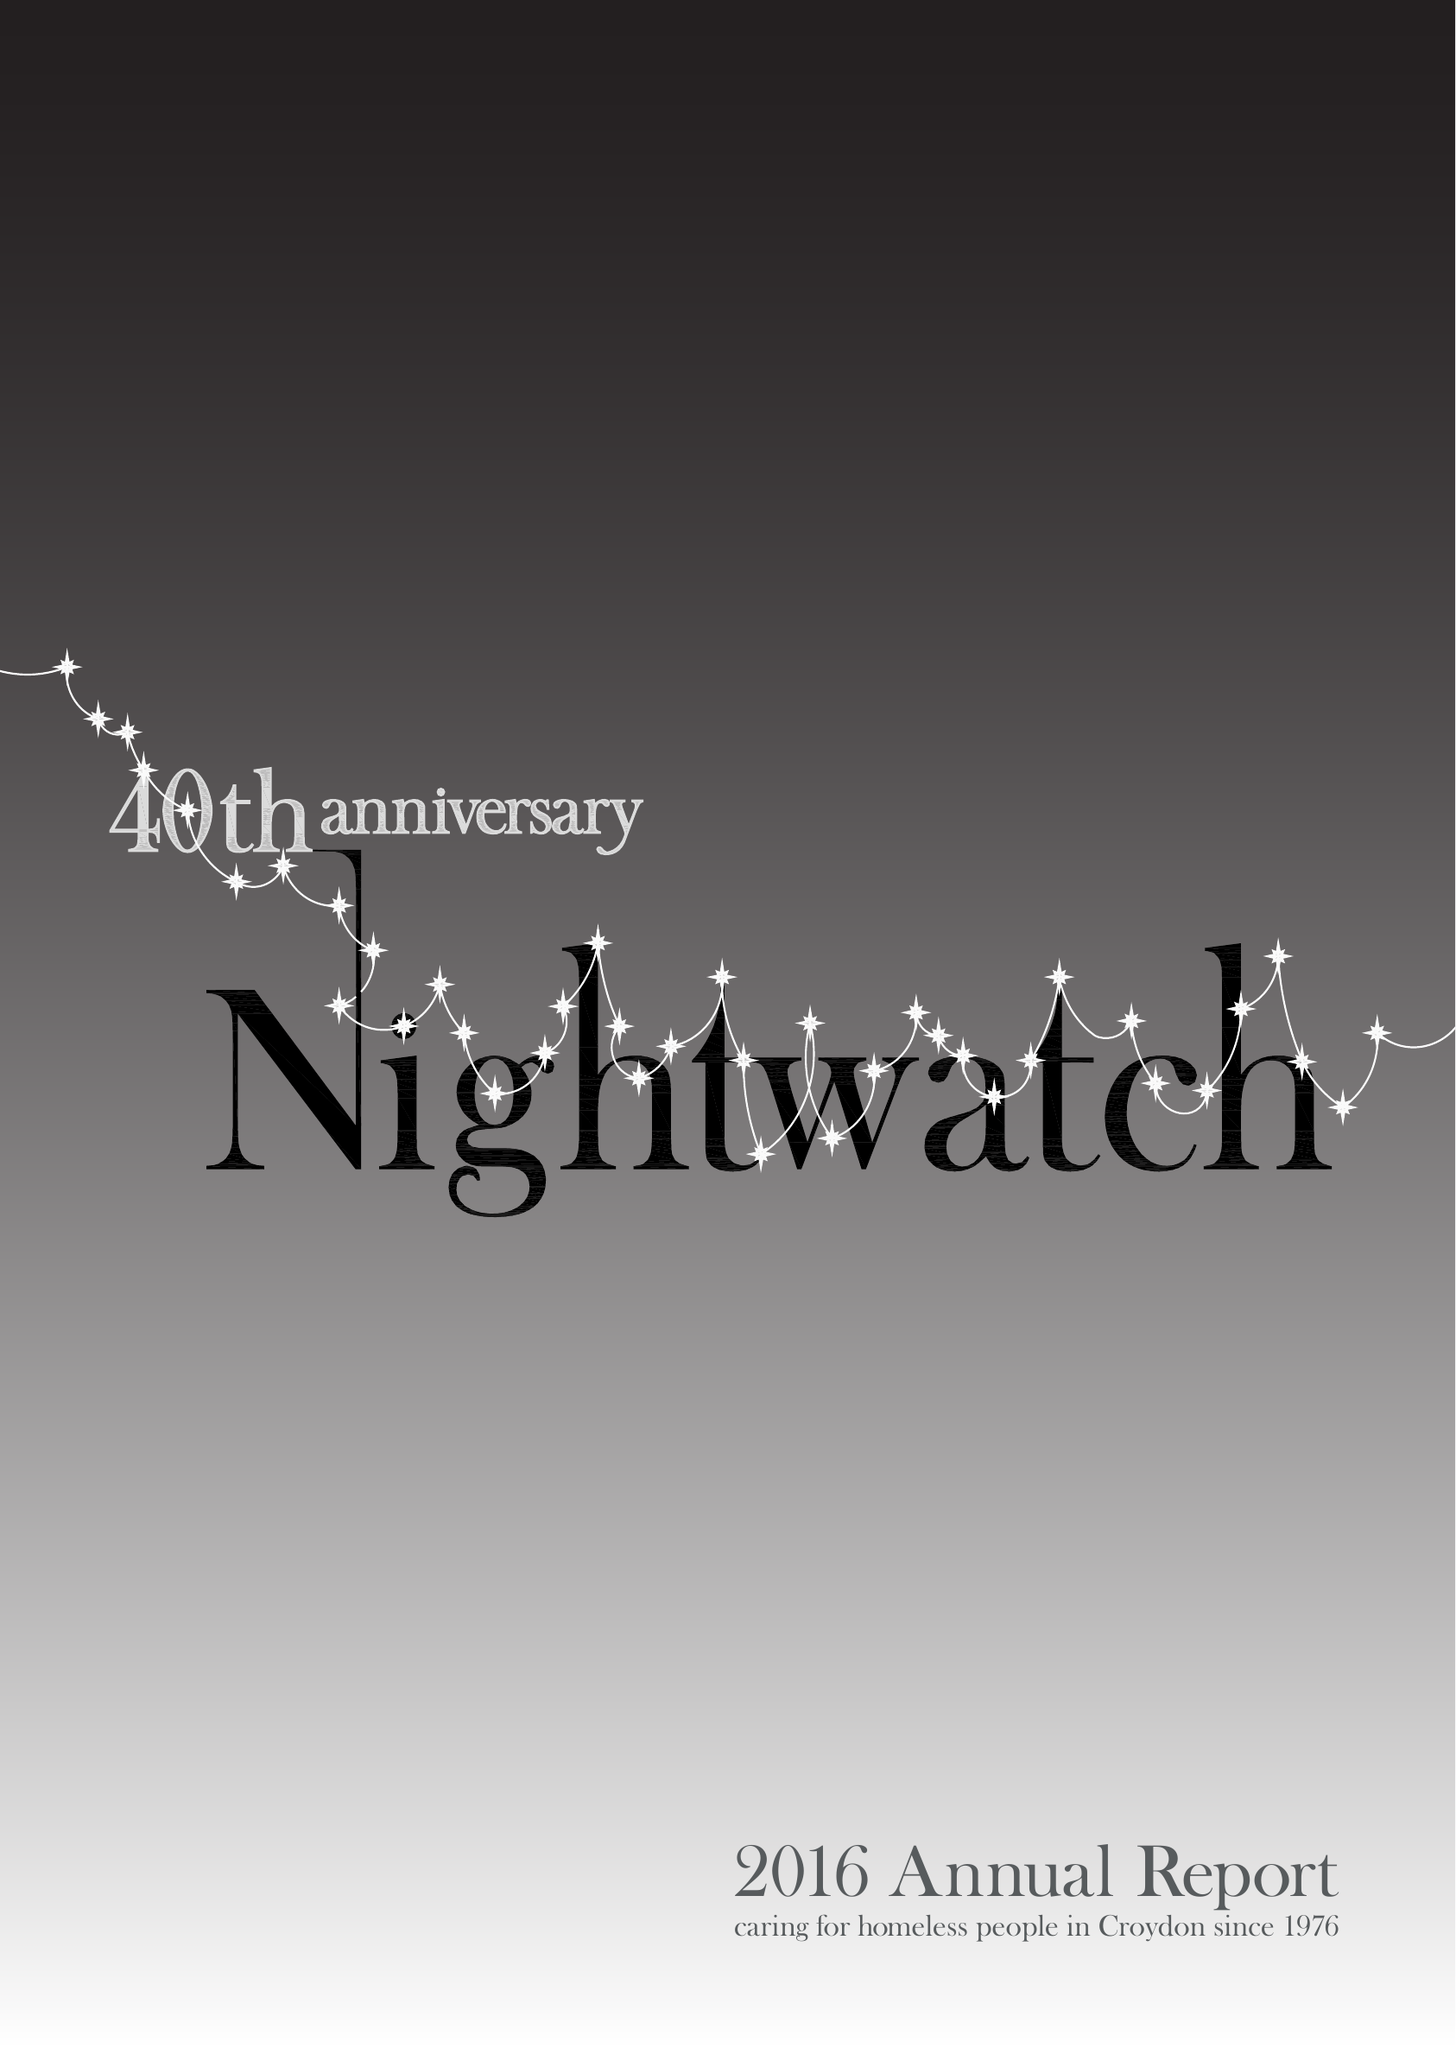What is the value for the address__post_town?
Answer the question using a single word or phrase. LONDON 